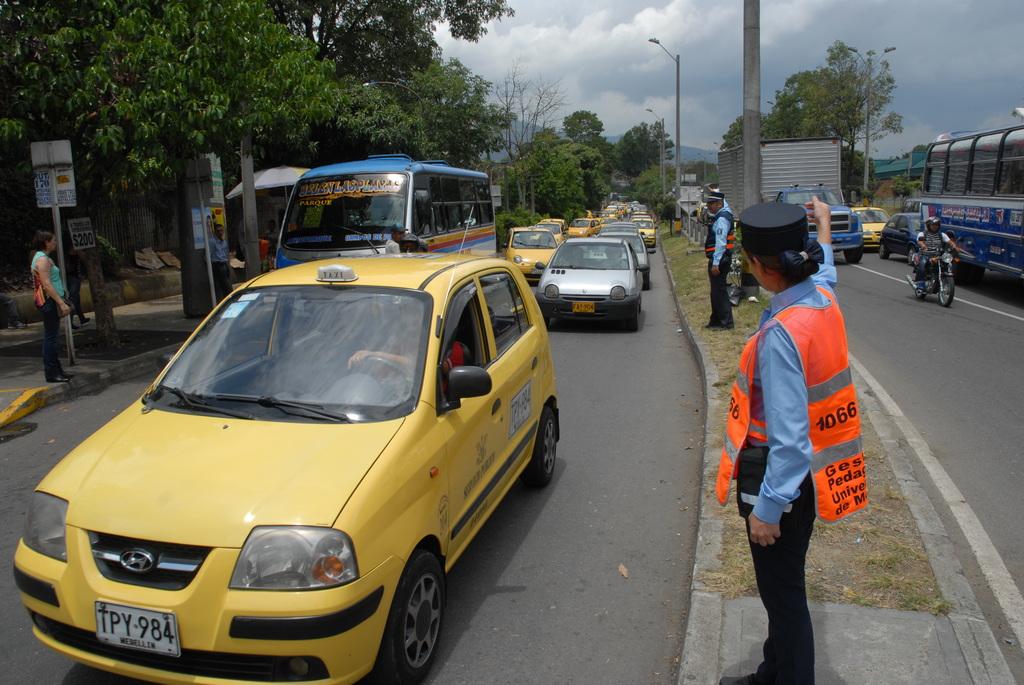What is the nearest yellow car's license plate number?
Offer a terse response. Tpy984. What number in on the back of the orange vest?
Offer a very short reply. 1066. 